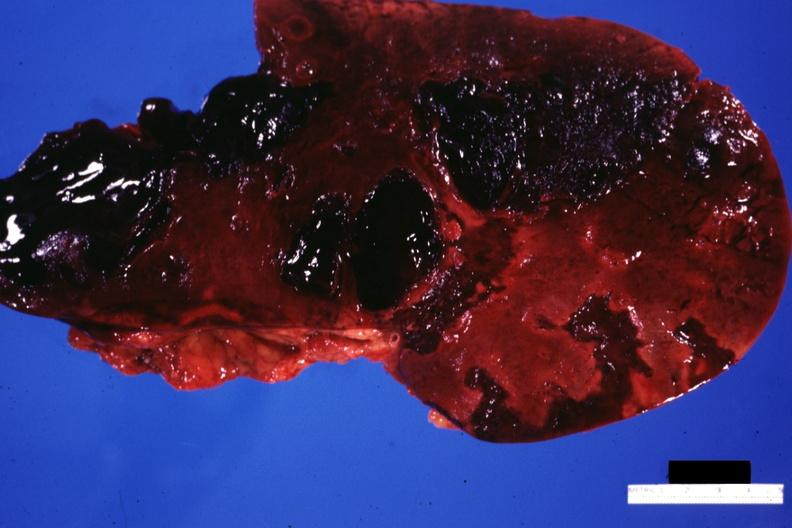does this image show frontal cut surface massive lacerations?
Answer the question using a single word or phrase. Yes 